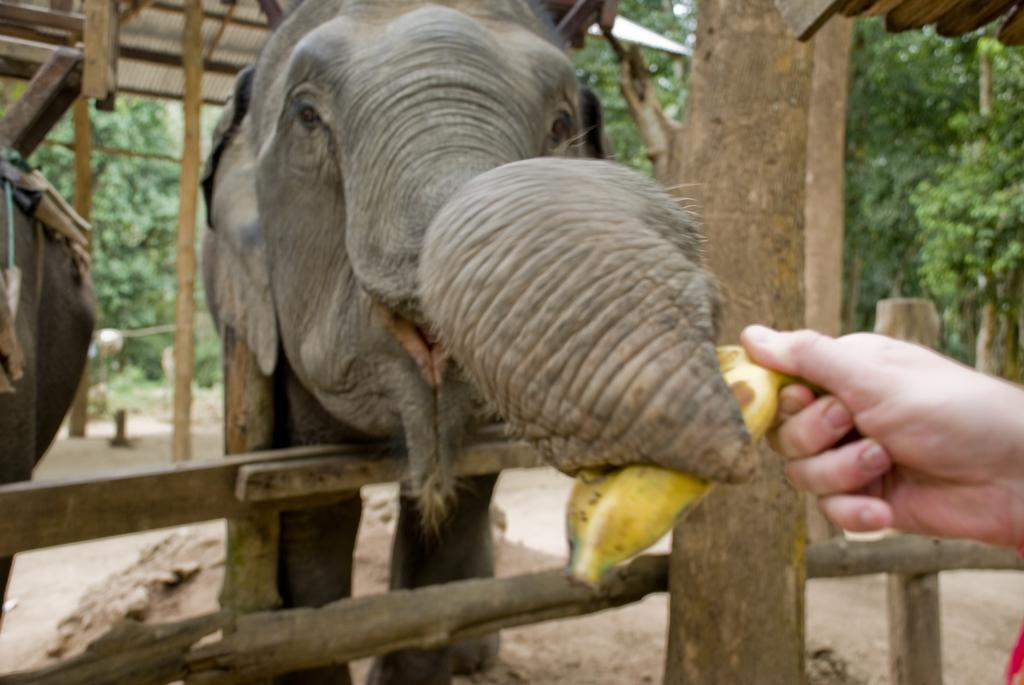What animals can be seen on the ground in the image? There are elephants on the ground in the image. What structure is present in the image? There is a fence in the image. What is the person holding in the image? The person is holding a banana in the image. What can be seen in the distance in the image? There is a shed visible in the background of the image, and trees are present in the background as well. Can you see the person's grandmother combing her hair in the image? There is no person's grandmother or comb present in the image. What type of net is being used to catch the elephants in the image? There is no net present in the image, and the elephants are not being caught. 